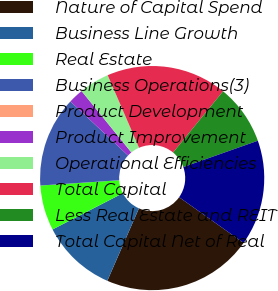Convert chart. <chart><loc_0><loc_0><loc_500><loc_500><pie_chart><fcel>Nature of Capital Spend<fcel>Business Line Growth<fcel>Real Estate<fcel>Business Operations(3)<fcel>Product Development<fcel>Product Improvement<fcel>Operational Efficiencies<fcel>Total Capital<fcel>Less Real Estate and REIT<fcel>Total Capital Net of Real<nl><fcel>21.74%<fcel>10.87%<fcel>6.52%<fcel>13.04%<fcel>0.0%<fcel>2.17%<fcel>4.35%<fcel>17.39%<fcel>8.7%<fcel>15.22%<nl></chart> 